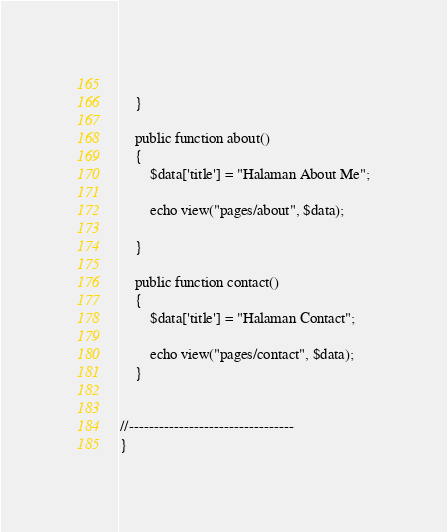Convert code to text. <code><loc_0><loc_0><loc_500><loc_500><_PHP_>		
	}

	public function about()
	{
		$data['title'] = "Halaman About Me";
		
		echo view("pages/about", $data);
		
	}

	public function contact()
	{
		$data['title'] = "Halaman Contact";
		
		echo view("pages/contact", $data);
	}


//---------------------------------
}
</code> 